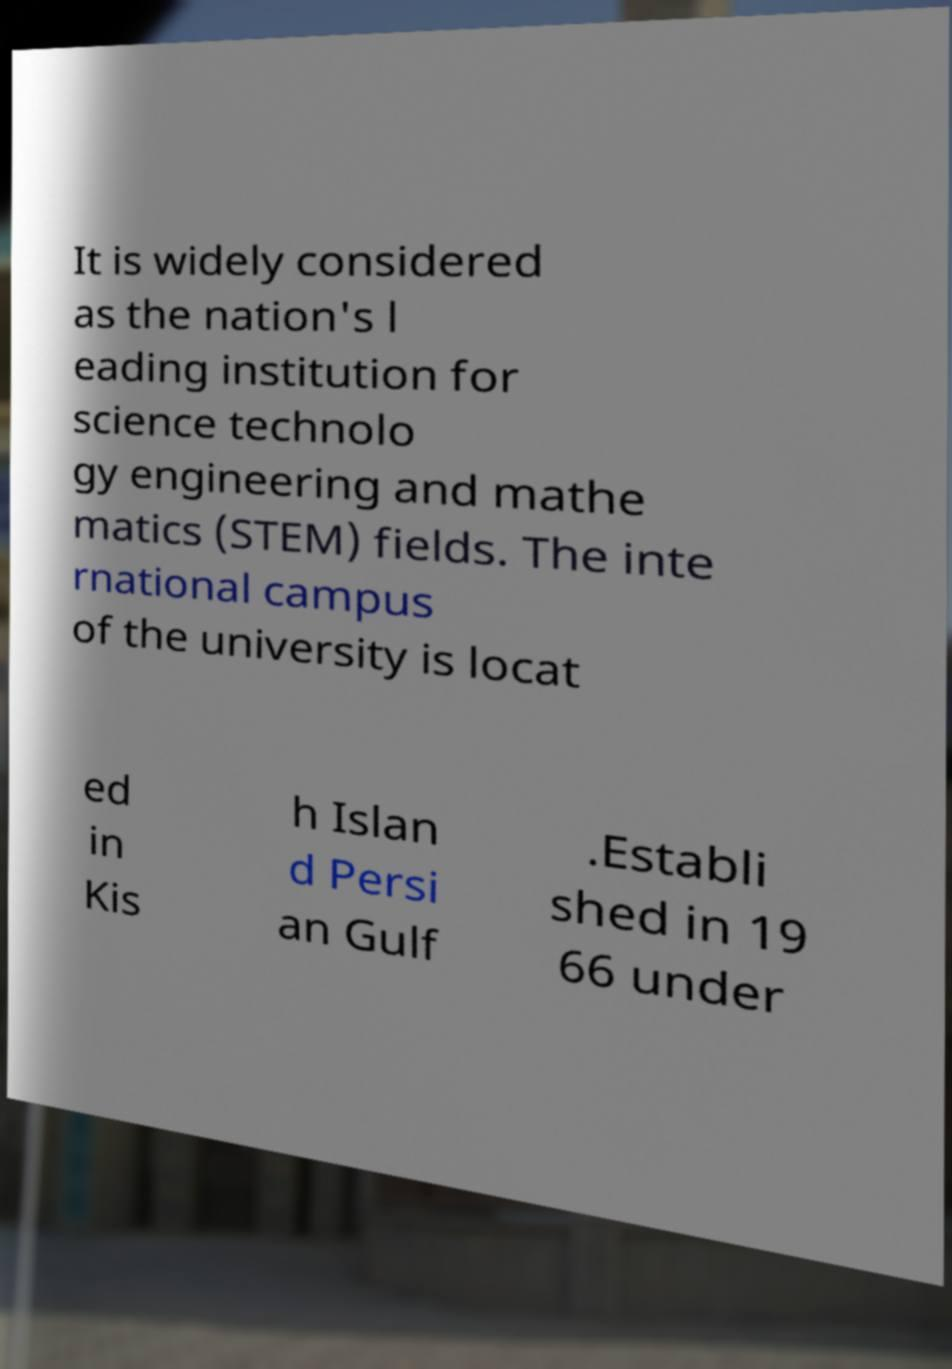For documentation purposes, I need the text within this image transcribed. Could you provide that? It is widely considered as the nation's l eading institution for science technolo gy engineering and mathe matics (STEM) fields. The inte rnational campus of the university is locat ed in Kis h Islan d Persi an Gulf .Establi shed in 19 66 under 